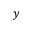<formula> <loc_0><loc_0><loc_500><loc_500>y</formula> 